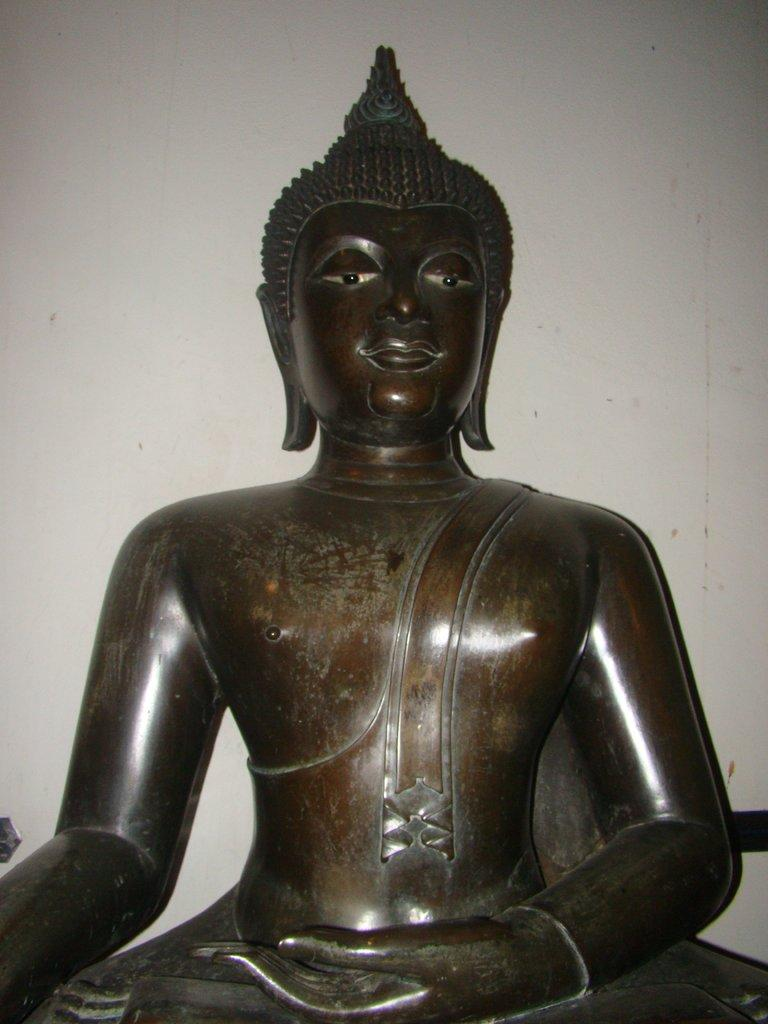What is the main subject of the image? There is a Buddha statue in the image. What can be seen in the background of the image? There is a white color wall in the background of the image. How many volleyballs are on the ground near the Buddha statue in the image? There are no volleyballs present in the image. What advice might the Buddha statue give to a grandmother in the image? There is no grandmother present in the image, and the Buddha statue is a statue, so it cannot give advice. 